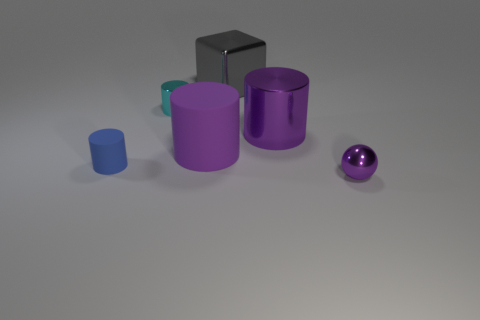What is the sphere in front of the rubber thing that is on the left side of the small metallic thing left of the purple metal cylinder made of?
Offer a terse response. Metal. Is the number of things less than the number of tiny blue cylinders?
Keep it short and to the point. No. Does the gray thing have the same material as the tiny blue cylinder?
Your answer should be very brief. No. What is the shape of the small metal object that is the same color as the big matte thing?
Offer a very short reply. Sphere. There is a small shiny object right of the block; is it the same color as the big matte thing?
Provide a succinct answer. Yes. How many large gray shiny objects are behind the rubber cylinder behind the blue matte cylinder?
Keep it short and to the point. 1. What color is the matte cylinder that is the same size as the gray metallic thing?
Provide a short and direct response. Purple. There is a small cylinder that is on the right side of the small matte cylinder; what material is it?
Your answer should be very brief. Metal. What is the material of the object that is right of the large gray block and behind the ball?
Provide a succinct answer. Metal. There is a matte object that is behind the blue matte cylinder; is it the same size as the large purple metallic cylinder?
Keep it short and to the point. Yes. 